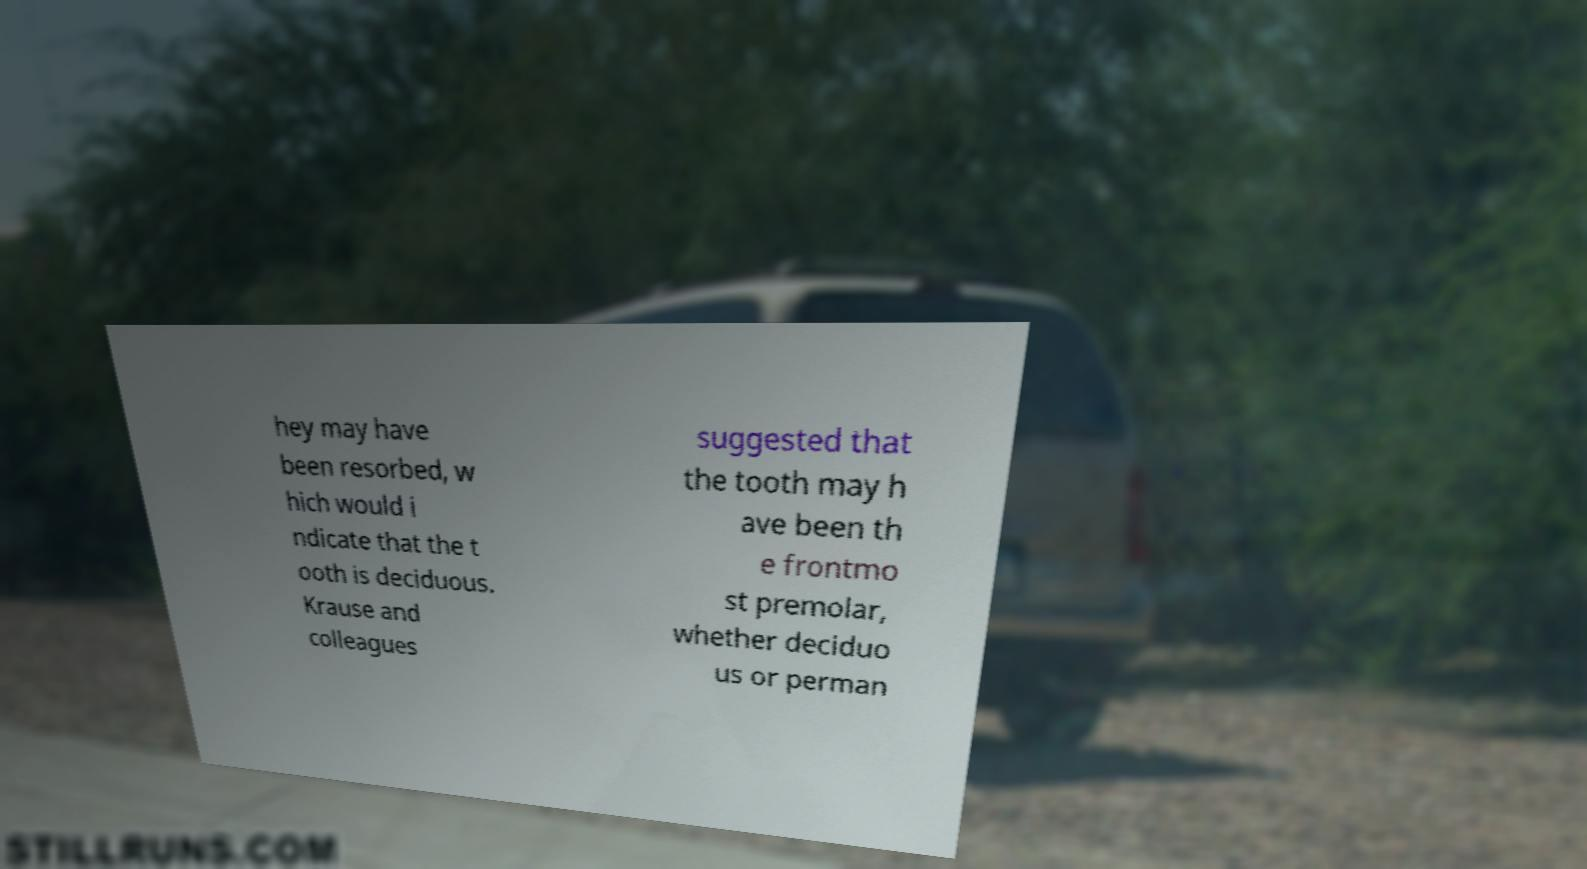Could you assist in decoding the text presented in this image and type it out clearly? hey may have been resorbed, w hich would i ndicate that the t ooth is deciduous. Krause and colleagues suggested that the tooth may h ave been th e frontmo st premolar, whether deciduo us or perman 